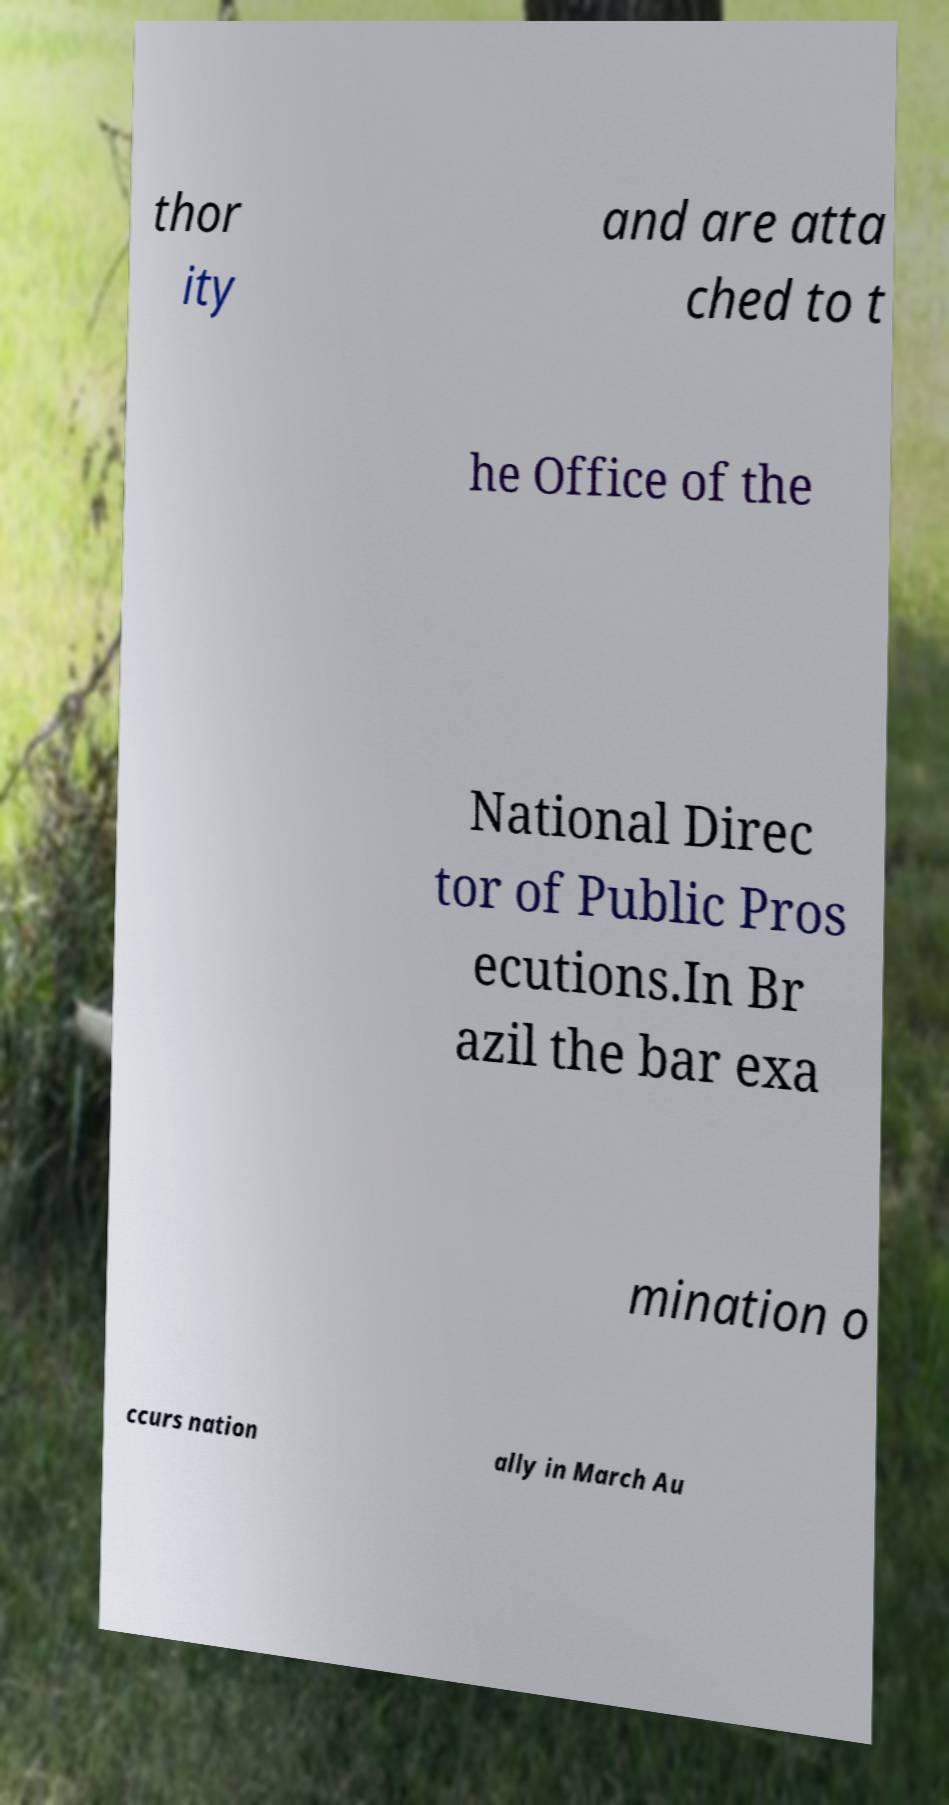There's text embedded in this image that I need extracted. Can you transcribe it verbatim? thor ity and are atta ched to t he Office of the National Direc tor of Public Pros ecutions.In Br azil the bar exa mination o ccurs nation ally in March Au 